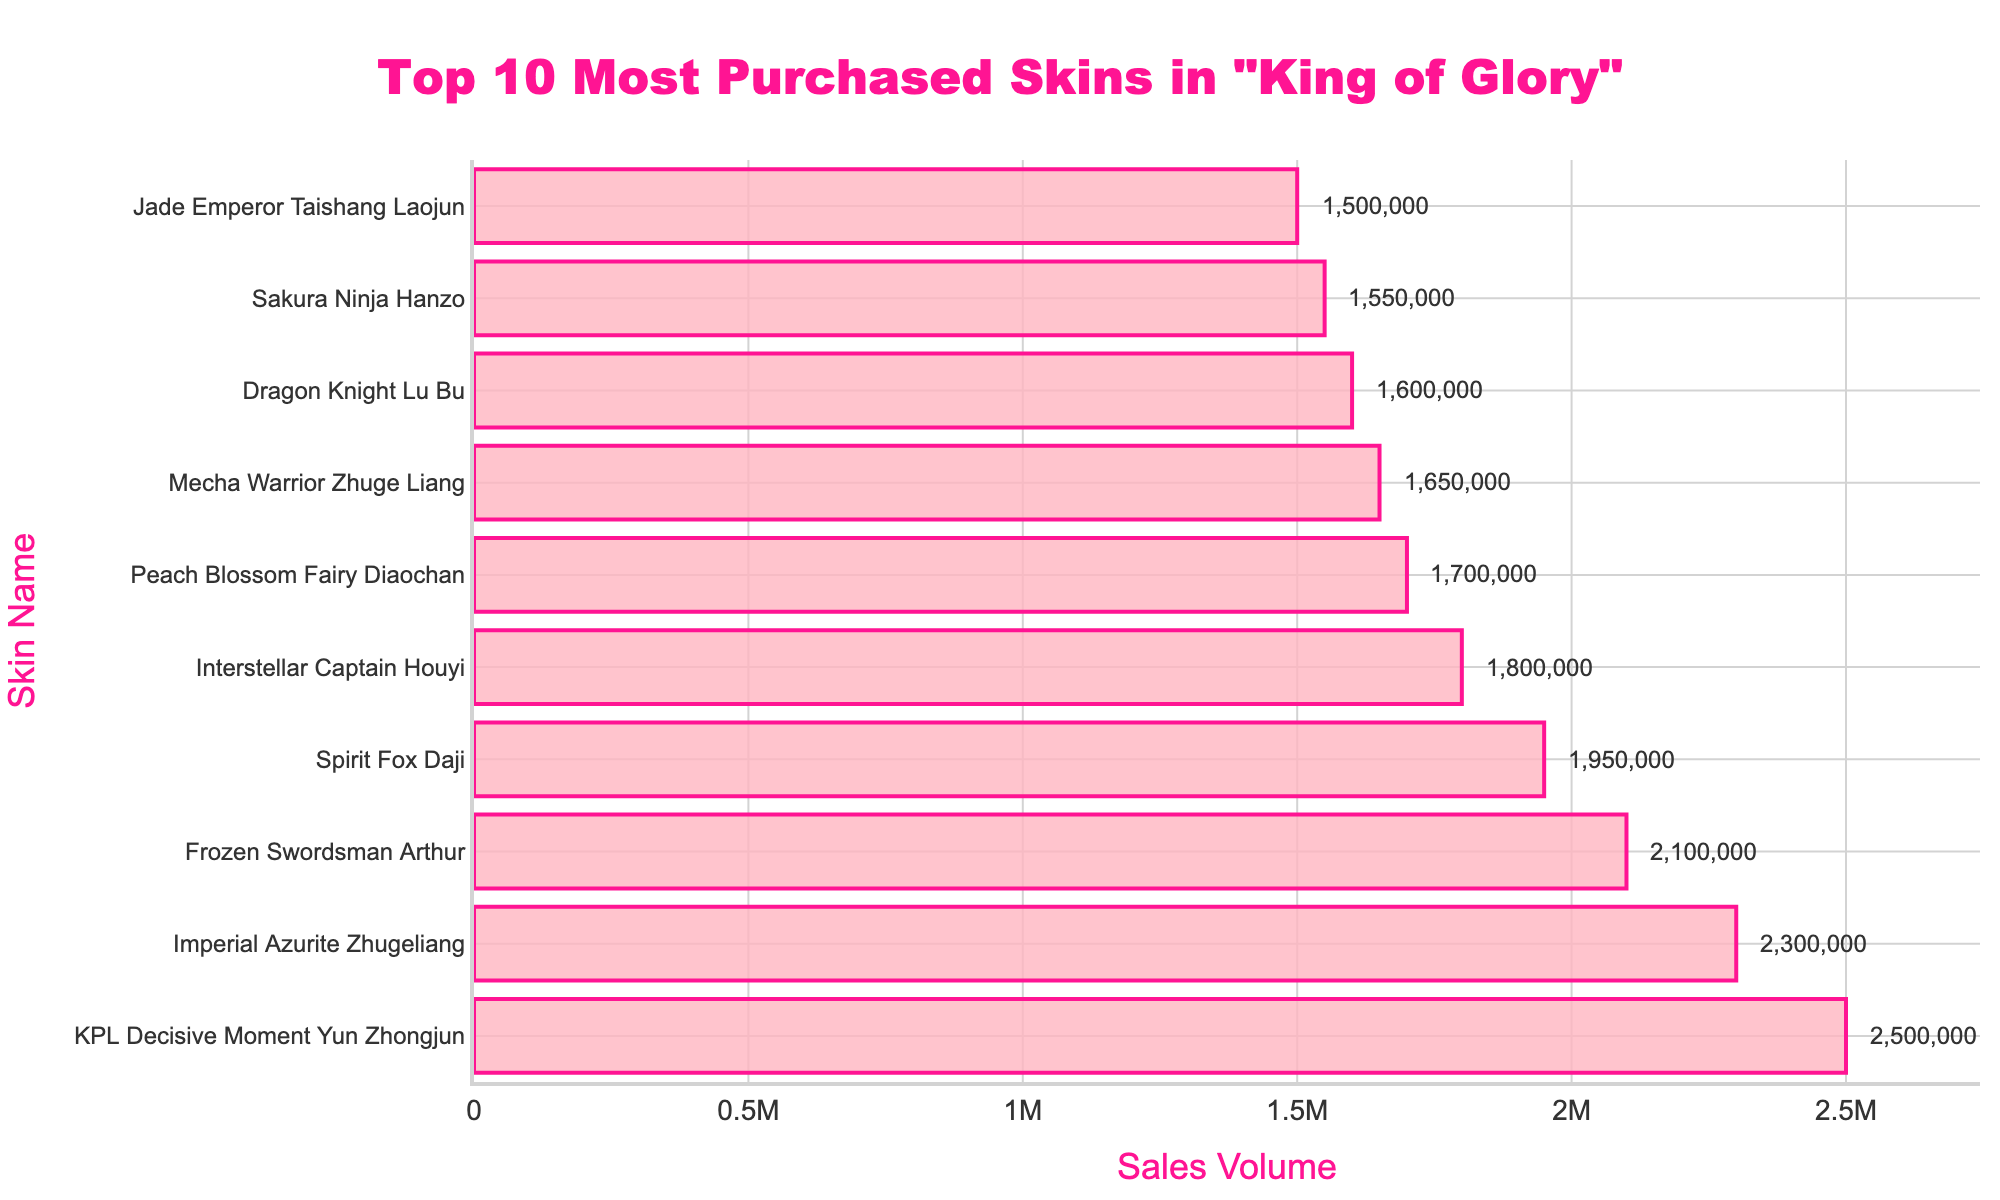Which skin has the highest sales volume? The highest sales volume is represented by the bar at the top of the chart. In this figure, the bar at the top is for "KPL Decisive Moment Yun Zhongjun" with 2,500,000 sales.
Answer: KPL Decisive Moment Yun Zhongjun What is the total sales volume for the top 3 most purchased skins? Add the sales volumes of the top three skins: 2,500,000 (KPL Decisive Moment Yun Zhongjun) + 2,300,000 (Imperial Azurite Zhugeliang) + 2,100,000 (Frozen Swordsman Arthur). The total is 2,500,000 + 2,300,000 + 2,100,000 = 6,900,000.
Answer: 6,900,000 Is the sales volume for "Spirit Fox Daji" more or less than "Interstellar Captain Houyi"? Compare the sales volumes of "Spirit Fox Daji" (1,950,000) and "Interstellar Captain Houyi" (1,800,000). The sales volume for "Spirit Fox Daji" is greater than "Interstellar Captain Houyi".
Answer: More What is the difference in sales volume between the highest and the lowest skin in the top 5? Subtract the sales volume of the lowest skin in the top 5 ("Interstellar Captain Houyi" with 1,800,000) from the highest ("KPL Decisive Moment Yun Zhongjun" with 2,500,000). The difference is 2,500,000 - 1,800,000 = 700,000.
Answer: 700,000 Which skin has the 4th highest sales volume? The fourth highest sales volume is represented by the fourth bar from the top, which is "Spirit Fox Daji" with 1,950,000 sales.
Answer: Spirit Fox Daji Compare the combined sales volume of the 2nd and 3rd skins to the sales volume of the 1st skin. Which is greater? Combine the sales volumes of the 2nd (Imperial Azurite Zhugeliang, 2,300,000) and 3rd (Frozen Swordsman Arthur, 2,100,000) skins. The total is 2,300,000 + 2,100,000 =  4,400,000. Compare this to the 1st skin (KPL Decisive Moment Yun Zhongjun, 2,500,000). 4,400,000 is greater than 2,500,000.
Answer: Combined sales of 2nd and 3rd are greater What is the average sales volume of the top 5 most purchased skins? Add the sales volumes of the top five skins: 2,500,000 (KPL Decisive Moment Yun Zhongjun) + 2,300,000 (Imperial Azurite Zhugeliang) + 2,100,000 (Frozen Swordsman Arthur) + 1,950,000 (Spirit Fox Daji) + 1,800,000 (Interstellar Captain Houyi). Divide the sum by 5. (2,500,000 + 2,300,000 + 2,100,000 + 1,950,000 + 1,800,000) / 5 = 10,650,000 / 5 = 2,130,000.
Answer: 2,130,000 How many skins have sales volumes greater than 2,000,000? Count the bars with sales volumes greater than 2,000,000. The skins are "KPL Decisive Moment Yun Zhongjun" (2,500,000), "Imperial Azurite Zhugeliang" (2,300,000), and "Frozen Swordsman Arthur" (2,100,000). There are 3 skins in total.
Answer: 3 What's the median sales volume of the top 5 skins? The median is the middle number in a sorted list. For the top 5 skins, the sorted sales volumes are 1,800,000, 1,950,000, 2,100,000, 2,300,000, and 2,500,000. The median value is the 3rd number, which is 2,100,000.
Answer: 2,100,000 